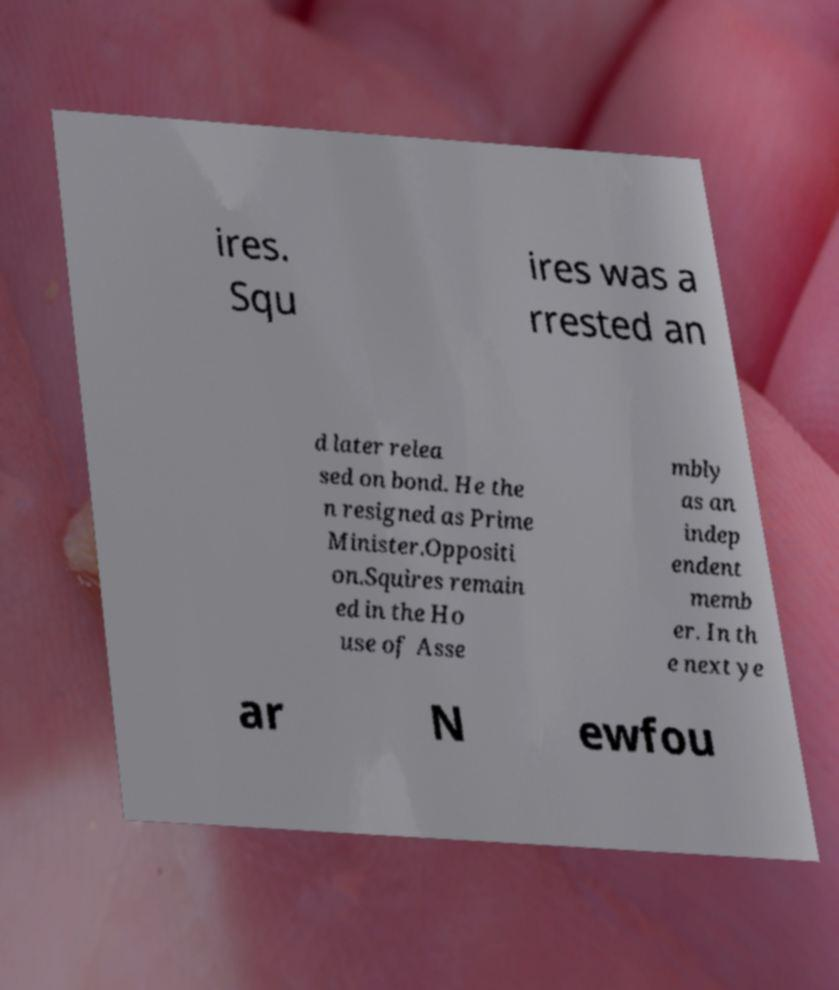Please identify and transcribe the text found in this image. ires. Squ ires was a rrested an d later relea sed on bond. He the n resigned as Prime Minister.Oppositi on.Squires remain ed in the Ho use of Asse mbly as an indep endent memb er. In th e next ye ar N ewfou 